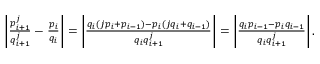Convert formula to latex. <formula><loc_0><loc_0><loc_500><loc_500>\begin{array} { r } { \left | \frac { p _ { i + 1 } ^ { j } } { q _ { i + 1 } ^ { j } } - \frac { p _ { i } } { q _ { i } } \right | = \left | \frac { q _ { i } ( j p _ { i } + p _ { i - 1 } ) - p _ { i } ( j q _ { i } + q _ { i - 1 } ) } { q _ { i } q _ { i + 1 } ^ { j } } \right | = \left | \frac { q _ { i } p _ { i - 1 } - p _ { i } q _ { i - 1 } } { q _ { i } q _ { i + 1 } ^ { j } } \right | . } \end{array}</formula> 